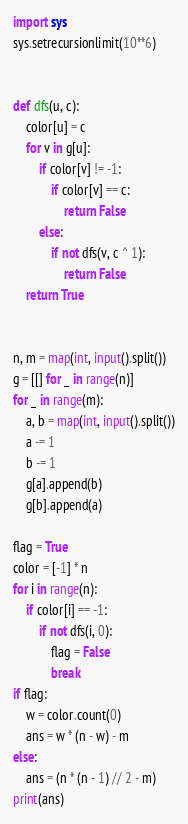<code> <loc_0><loc_0><loc_500><loc_500><_Python_>import sys
sys.setrecursionlimit(10**6)


def dfs(u, c):
    color[u] = c
    for v in g[u]:
        if color[v] != -1:
            if color[v] == c:
                return False
        else:
            if not dfs(v, c ^ 1):
                return False
    return True


n, m = map(int, input().split())
g = [[] for _ in range(n)]
for _ in range(m):
    a, b = map(int, input().split())
    a -= 1
    b -= 1
    g[a].append(b)
    g[b].append(a)

flag = True
color = [-1] * n
for i in range(n):
    if color[i] == -1:
        if not dfs(i, 0):
            flag = False
            break
if flag:
    w = color.count(0)
    ans = w * (n - w) - m
else:
    ans = (n * (n - 1) // 2 - m)
print(ans)</code> 